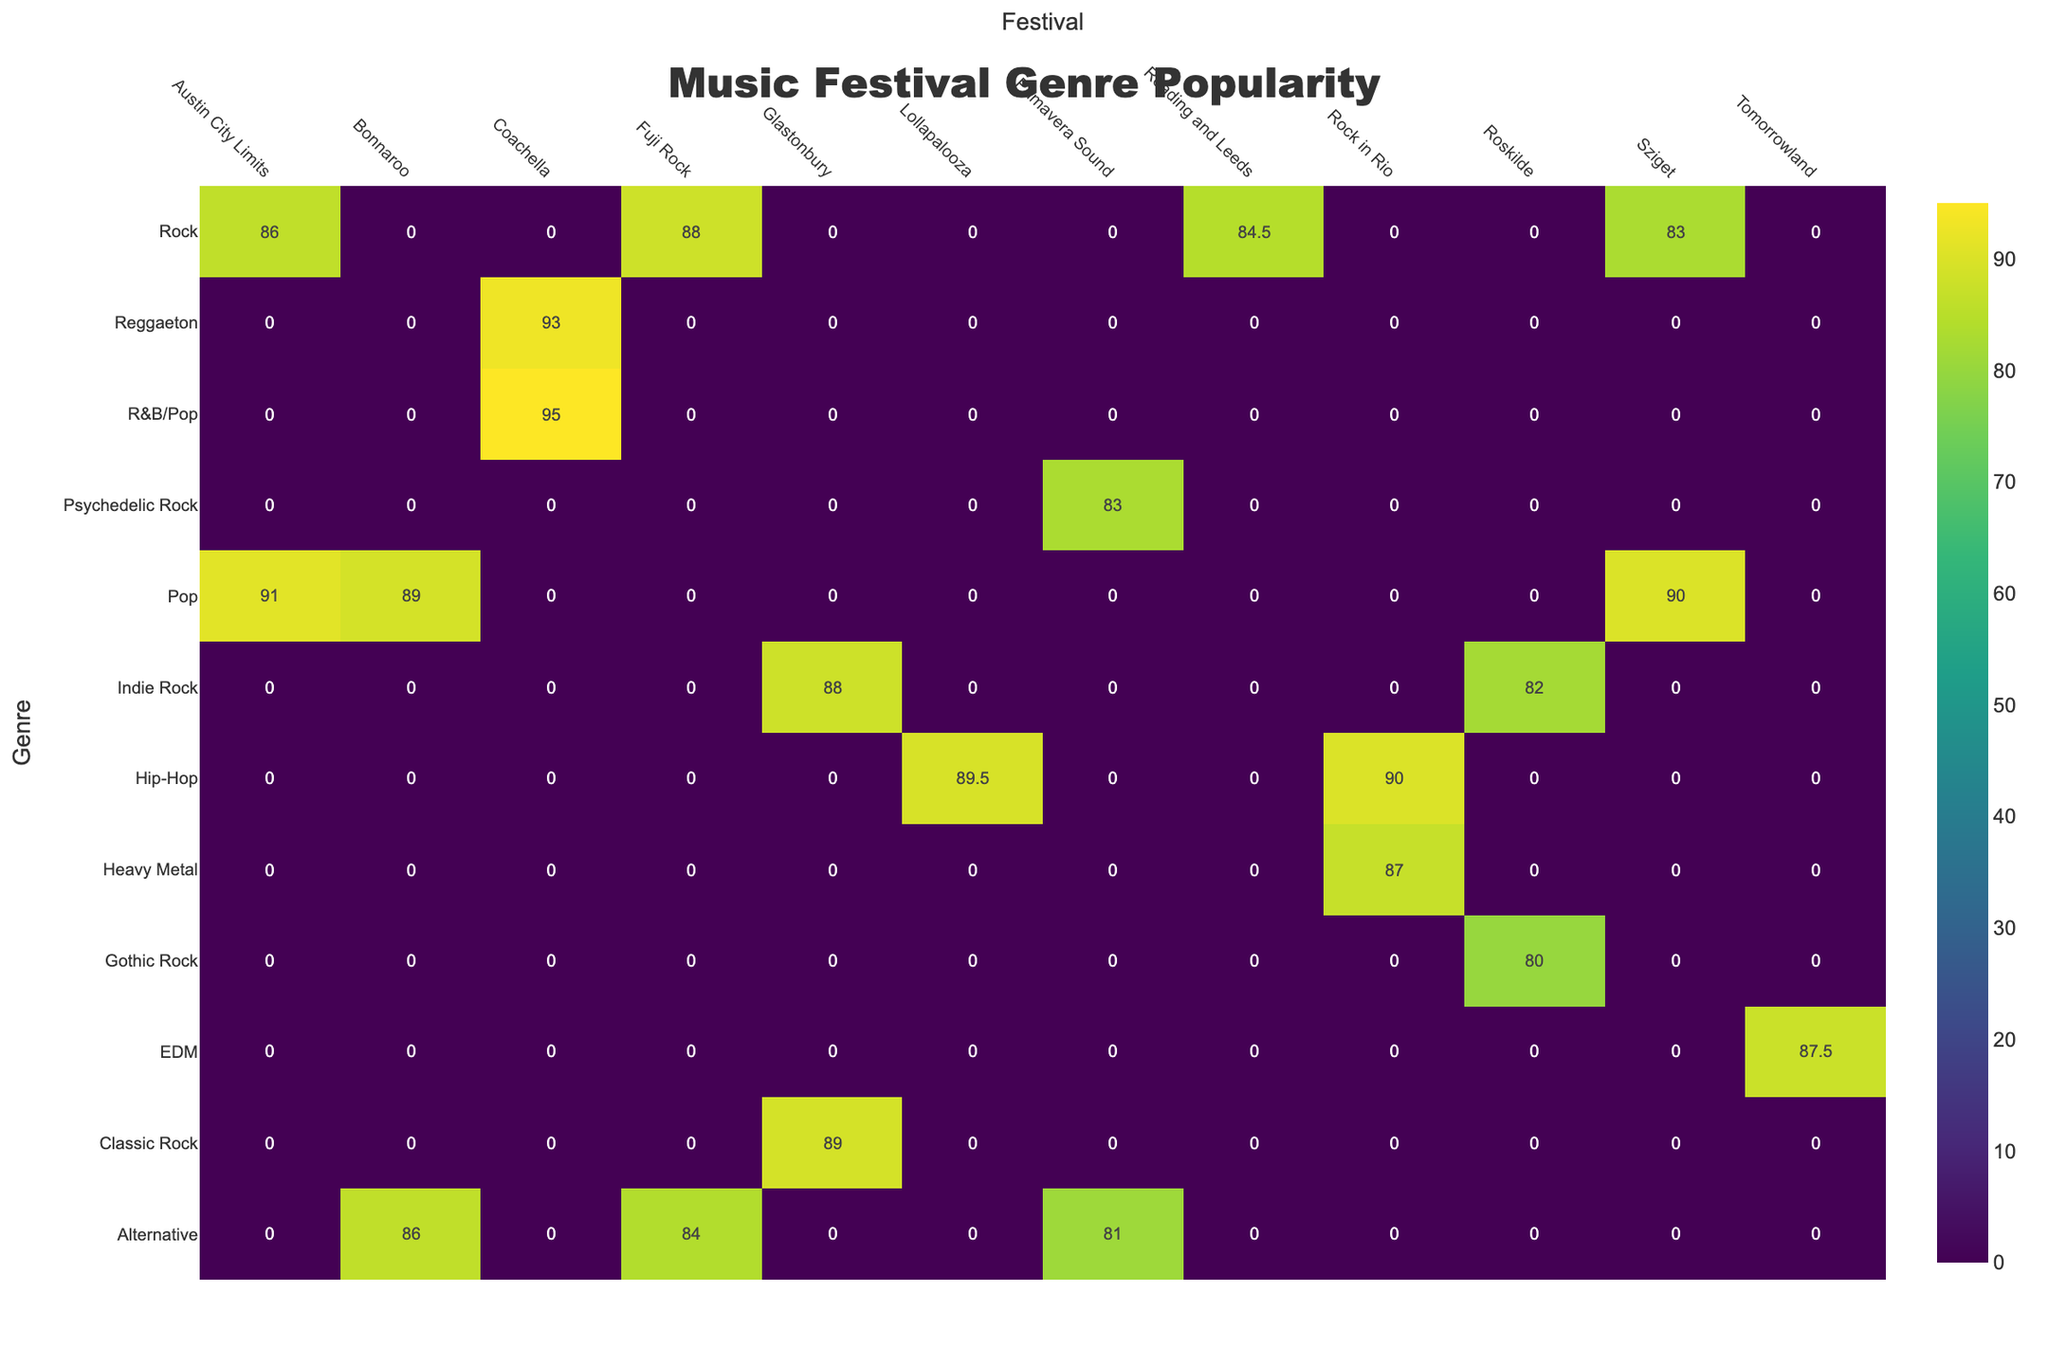Which genre has the highest average popularity at Coachella? By looking at the table under the Coachella column, we can see that the average popularity of R&B/Pop is 95, which is higher than any other genre listed under that festival.
Answer: R&B/Pop What is the average popularity of Indie Rock artists across all festivals? To find the average popularity of Indie Rock, we first identify the popularity values for all Indie Rock artists: Arctic Monkeys (88) and The Strokes (82). The average is calculated as (88 + 82) / 2 = 85.
Answer: 85 Did any festival feature Heavy Metal artists? Checking the table, we see that Rock in Rio includes Metallica, which confirms that Heavy Metal artists were featured at this festival.
Answer: Yes Which festival has the lowest average popularity for Rock genre performers? The Rock genre has performances by The Killers (84), Foo Fighters (88), Muse (85), Red Hot Chili Peppers (86), and Kings of Leon (83). The lowest popularity here is by The Killers, meaning Reading and Leeds has the lowest average popularity of 84 for Rock artists.
Answer: Reading and Leeds What is the difference in average popularity between Pop and Hip-Hop artists at Lollapalooza? At Lollapalooza, the average popularity for Pop (Billie Eilish is not listed here) would typically be considered based on Tyler The Creator (87). The average popularity for Hip-Hop artists is Kendrick Lamar (92) and Tyler The Creator (87), leading to an average of 89.5 for Hip-Hop. The difference is calculated as 89.5 - 87 = 2.5, showing that Hip-Hop is more popular by 2.5 points on average than Pop.
Answer: 2.5 Which artist has the highest critical score and at which festival do they perform? Scanning through the table, Beyoncé has the highest critical score of 92 and performs at Coachella, making her the artist with the highest score overall.
Answer: Beyoncé at Coachella 